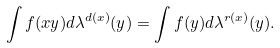Convert formula to latex. <formula><loc_0><loc_0><loc_500><loc_500>\int f ( x y ) d \lambda ^ { d ( x ) } ( y ) = \int f ( y ) d \lambda ^ { r ( x ) } ( y ) .</formula> 